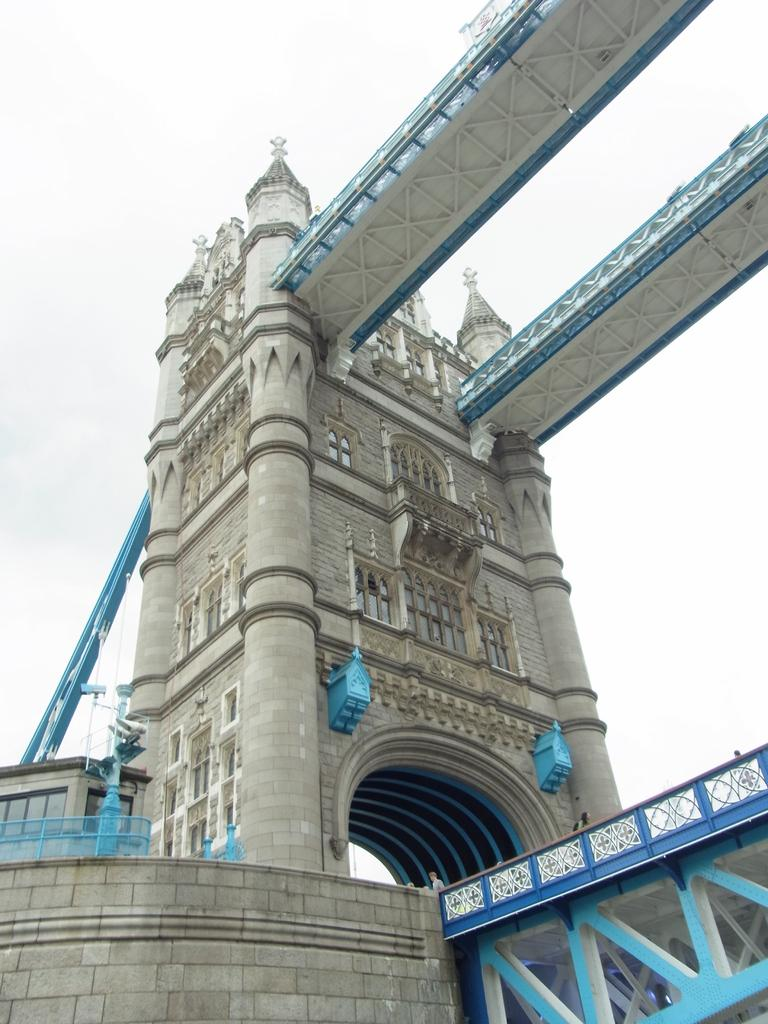What type of structure is depicted in the image? There is a tower bridge in the image. What impulse is driving the system in the image? There is no system or impulse present in the image; it is a static representation of a tower bridge. 